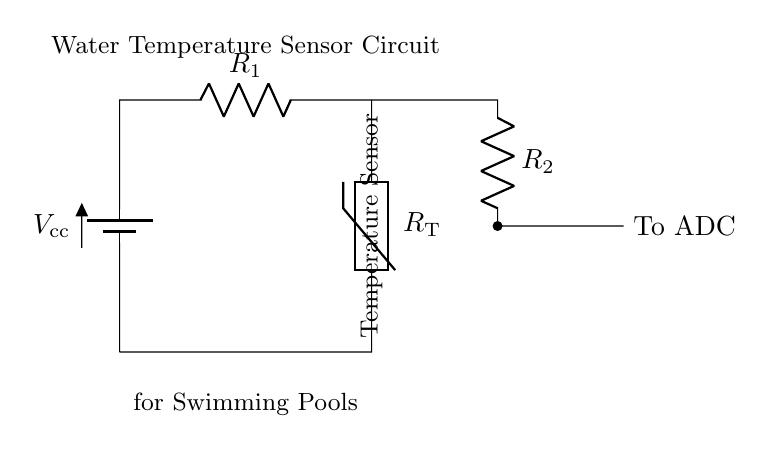What type of sensor is used in this circuit? The circuit diagram identifies the sensor as a thermistor, indicated by the label. A thermistor is a temperature-sensitive resistor whose resistance changes with temperature.
Answer: thermistor What does R1 represent in this circuit? R1 is a resistor that is part of the voltage divider circuit. It works together with the thermistor to create the voltage that signals the temperature reading.
Answer: resistor How many resistors are there in this circuit? By observing the circuit diagram, there are two resistors: R1 and R2. Each plays a role in the function of the circuit.
Answer: two What is the purpose of the ADC in this circuit? The ADC, or Analog to Digital Converter, is used to convert the analog voltage from the thermistor and resistors into a digital signal that a microcontroller can process for temperature monitoring.
Answer: convert signal What is the connection between R2 and the ADC? R2 connects to the ADC as the output of the voltage divider formed by R1 and the thermistor, which provides the temperature-dependent voltage to be digitized.
Answer: output of voltage divider What does the battery in this circuit provide? The battery provides a constant voltage supply necessary for the operation of the circuit, enabling current flow through the components.
Answer: constant voltage Why is the thermistor placed in this circuit? The thermistor is used for temperature sensing; its resistance varies with temperature changes, allowing for accurate temperature measurement in the swimming pool environment.
Answer: temperature sensing 